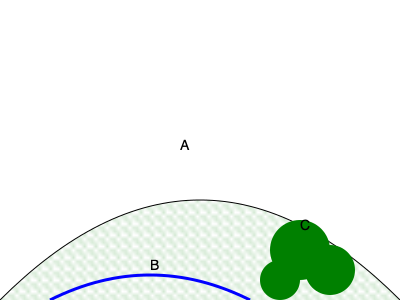In the topographical map of an ancient battlefield, which feature would provide the best strategic advantage for a defending army, and why? To answer this question, let's analyze each feature on the map:

1. Feature A: This is the top of a hill. Hills provide several advantages:
   - Elevated position for better visibility of approaching enemies
   - Advantage in ranged combat (arrows, catapults)
   - Attackers must expend more energy to reach defenders

2. Feature B: This is a river. Rivers can be useful but have limitations:
   - Natural barrier to slow down attackers
   - Can protect one flank of the defending army
   - However, it may limit the defender's retreat options

3. Feature C: This is a forested area. Forests offer:
   - Cover and concealment for troops
   - Potential for ambushes
   - Can slow down attacking forces

Comparing these features:
- The hill (A) provides the best overall strategic advantage. It offers superior visibility, combat advantage, and doesn't limit movement like the river.
- The river (B) is useful but less versatile than the hill.
- The forest (C) is good for concealment but doesn't offer the same tactical advantages as high ground.

Therefore, Feature A (the hill) would provide the best strategic advantage for a defending army.
Answer: Feature A (the hill) 